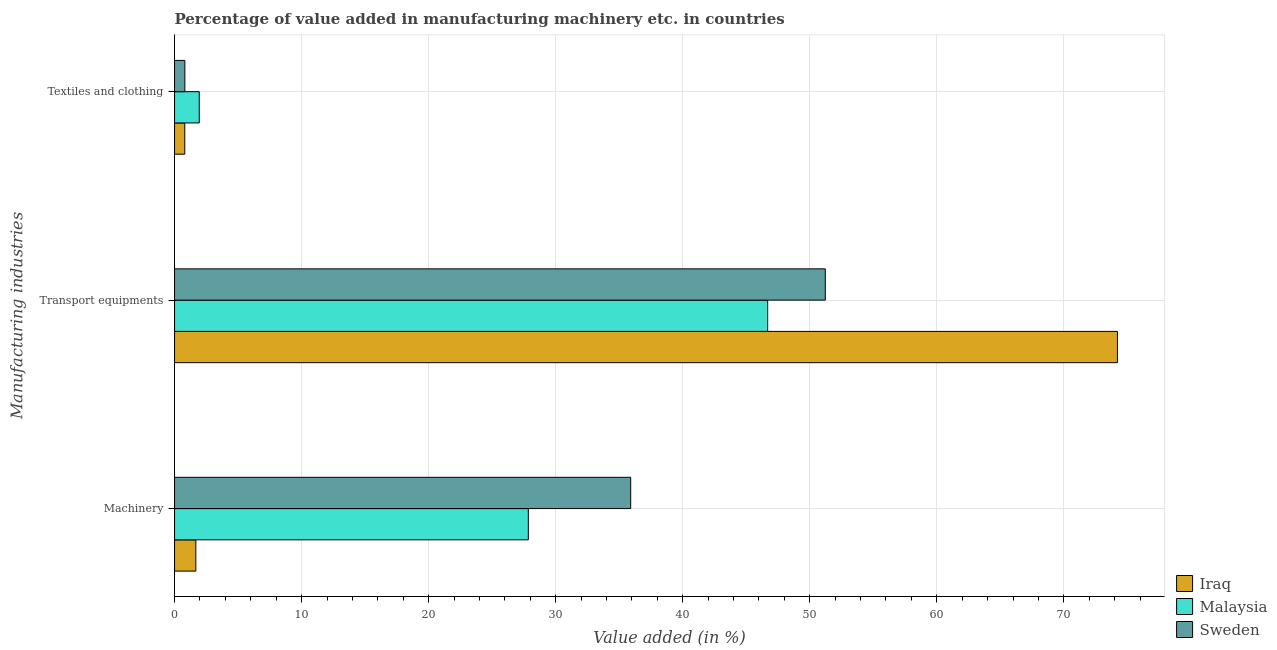How many different coloured bars are there?
Provide a short and direct response. 3. How many groups of bars are there?
Keep it short and to the point. 3. Are the number of bars per tick equal to the number of legend labels?
Offer a terse response. Yes. Are the number of bars on each tick of the Y-axis equal?
Your response must be concise. Yes. What is the label of the 1st group of bars from the top?
Provide a short and direct response. Textiles and clothing. What is the value added in manufacturing textile and clothing in Malaysia?
Your answer should be very brief. 1.95. Across all countries, what is the maximum value added in manufacturing machinery?
Keep it short and to the point. 35.91. Across all countries, what is the minimum value added in manufacturing machinery?
Provide a short and direct response. 1.68. In which country was the value added in manufacturing textile and clothing maximum?
Make the answer very short. Malaysia. In which country was the value added in manufacturing transport equipments minimum?
Offer a terse response. Malaysia. What is the total value added in manufacturing transport equipments in the graph?
Your answer should be compact. 172.14. What is the difference between the value added in manufacturing machinery in Sweden and that in Iraq?
Offer a very short reply. 34.23. What is the difference between the value added in manufacturing textile and clothing in Sweden and the value added in manufacturing machinery in Iraq?
Provide a succinct answer. -0.86. What is the average value added in manufacturing machinery per country?
Offer a terse response. 21.81. What is the difference between the value added in manufacturing textile and clothing and value added in manufacturing transport equipments in Sweden?
Offer a terse response. -50.41. What is the ratio of the value added in manufacturing machinery in Iraq to that in Malaysia?
Make the answer very short. 0.06. Is the difference between the value added in manufacturing machinery in Malaysia and Sweden greater than the difference between the value added in manufacturing textile and clothing in Malaysia and Sweden?
Your answer should be compact. No. What is the difference between the highest and the second highest value added in manufacturing transport equipments?
Your answer should be compact. 23. What is the difference between the highest and the lowest value added in manufacturing textile and clothing?
Your answer should be compact. 1.14. In how many countries, is the value added in manufacturing machinery greater than the average value added in manufacturing machinery taken over all countries?
Offer a very short reply. 2. What does the 3rd bar from the bottom in Machinery represents?
Keep it short and to the point. Sweden. How many bars are there?
Keep it short and to the point. 9. How many countries are there in the graph?
Your answer should be very brief. 3. What is the difference between two consecutive major ticks on the X-axis?
Your response must be concise. 10. Does the graph contain any zero values?
Offer a terse response. No. Does the graph contain grids?
Your answer should be compact. Yes. How many legend labels are there?
Offer a very short reply. 3. What is the title of the graph?
Provide a succinct answer. Percentage of value added in manufacturing machinery etc. in countries. Does "Mongolia" appear as one of the legend labels in the graph?
Offer a terse response. No. What is the label or title of the X-axis?
Ensure brevity in your answer.  Value added (in %). What is the label or title of the Y-axis?
Ensure brevity in your answer.  Manufacturing industries. What is the Value added (in %) in Iraq in Machinery?
Give a very brief answer. 1.68. What is the Value added (in %) in Malaysia in Machinery?
Give a very brief answer. 27.85. What is the Value added (in %) of Sweden in Machinery?
Provide a succinct answer. 35.91. What is the Value added (in %) of Iraq in Transport equipments?
Give a very brief answer. 74.22. What is the Value added (in %) in Malaysia in Transport equipments?
Give a very brief answer. 46.69. What is the Value added (in %) in Sweden in Transport equipments?
Your response must be concise. 51.22. What is the Value added (in %) in Iraq in Textiles and clothing?
Make the answer very short. 0.8. What is the Value added (in %) of Malaysia in Textiles and clothing?
Offer a very short reply. 1.95. What is the Value added (in %) of Sweden in Textiles and clothing?
Your answer should be compact. 0.81. Across all Manufacturing industries, what is the maximum Value added (in %) of Iraq?
Ensure brevity in your answer.  74.22. Across all Manufacturing industries, what is the maximum Value added (in %) in Malaysia?
Give a very brief answer. 46.69. Across all Manufacturing industries, what is the maximum Value added (in %) in Sweden?
Ensure brevity in your answer.  51.22. Across all Manufacturing industries, what is the minimum Value added (in %) in Iraq?
Give a very brief answer. 0.8. Across all Manufacturing industries, what is the minimum Value added (in %) in Malaysia?
Provide a succinct answer. 1.95. Across all Manufacturing industries, what is the minimum Value added (in %) of Sweden?
Offer a terse response. 0.81. What is the total Value added (in %) of Iraq in the graph?
Your answer should be very brief. 76.7. What is the total Value added (in %) in Malaysia in the graph?
Offer a terse response. 76.48. What is the total Value added (in %) of Sweden in the graph?
Offer a very short reply. 87.94. What is the difference between the Value added (in %) of Iraq in Machinery and that in Transport equipments?
Keep it short and to the point. -72.55. What is the difference between the Value added (in %) of Malaysia in Machinery and that in Transport equipments?
Your answer should be very brief. -18.84. What is the difference between the Value added (in %) in Sweden in Machinery and that in Transport equipments?
Make the answer very short. -15.32. What is the difference between the Value added (in %) of Iraq in Machinery and that in Textiles and clothing?
Ensure brevity in your answer.  0.87. What is the difference between the Value added (in %) in Malaysia in Machinery and that in Textiles and clothing?
Ensure brevity in your answer.  25.9. What is the difference between the Value added (in %) in Sweden in Machinery and that in Textiles and clothing?
Provide a short and direct response. 35.09. What is the difference between the Value added (in %) in Iraq in Transport equipments and that in Textiles and clothing?
Your response must be concise. 73.42. What is the difference between the Value added (in %) of Malaysia in Transport equipments and that in Textiles and clothing?
Keep it short and to the point. 44.74. What is the difference between the Value added (in %) in Sweden in Transport equipments and that in Textiles and clothing?
Your answer should be very brief. 50.41. What is the difference between the Value added (in %) in Iraq in Machinery and the Value added (in %) in Malaysia in Transport equipments?
Make the answer very short. -45.01. What is the difference between the Value added (in %) in Iraq in Machinery and the Value added (in %) in Sweden in Transport equipments?
Give a very brief answer. -49.55. What is the difference between the Value added (in %) of Malaysia in Machinery and the Value added (in %) of Sweden in Transport equipments?
Offer a very short reply. -23.38. What is the difference between the Value added (in %) of Iraq in Machinery and the Value added (in %) of Malaysia in Textiles and clothing?
Keep it short and to the point. -0.27. What is the difference between the Value added (in %) of Iraq in Machinery and the Value added (in %) of Sweden in Textiles and clothing?
Keep it short and to the point. 0.86. What is the difference between the Value added (in %) in Malaysia in Machinery and the Value added (in %) in Sweden in Textiles and clothing?
Provide a succinct answer. 27.04. What is the difference between the Value added (in %) in Iraq in Transport equipments and the Value added (in %) in Malaysia in Textiles and clothing?
Ensure brevity in your answer.  72.28. What is the difference between the Value added (in %) of Iraq in Transport equipments and the Value added (in %) of Sweden in Textiles and clothing?
Ensure brevity in your answer.  73.41. What is the difference between the Value added (in %) in Malaysia in Transport equipments and the Value added (in %) in Sweden in Textiles and clothing?
Provide a succinct answer. 45.88. What is the average Value added (in %) of Iraq per Manufacturing industries?
Provide a short and direct response. 25.57. What is the average Value added (in %) of Malaysia per Manufacturing industries?
Provide a succinct answer. 25.49. What is the average Value added (in %) of Sweden per Manufacturing industries?
Give a very brief answer. 29.31. What is the difference between the Value added (in %) of Iraq and Value added (in %) of Malaysia in Machinery?
Offer a very short reply. -26.17. What is the difference between the Value added (in %) in Iraq and Value added (in %) in Sweden in Machinery?
Your answer should be compact. -34.23. What is the difference between the Value added (in %) of Malaysia and Value added (in %) of Sweden in Machinery?
Offer a very short reply. -8.06. What is the difference between the Value added (in %) in Iraq and Value added (in %) in Malaysia in Transport equipments?
Provide a short and direct response. 27.53. What is the difference between the Value added (in %) of Iraq and Value added (in %) of Sweden in Transport equipments?
Your answer should be compact. 23. What is the difference between the Value added (in %) in Malaysia and Value added (in %) in Sweden in Transport equipments?
Offer a very short reply. -4.54. What is the difference between the Value added (in %) in Iraq and Value added (in %) in Malaysia in Textiles and clothing?
Your answer should be compact. -1.14. What is the difference between the Value added (in %) in Iraq and Value added (in %) in Sweden in Textiles and clothing?
Your answer should be very brief. -0.01. What is the difference between the Value added (in %) of Malaysia and Value added (in %) of Sweden in Textiles and clothing?
Keep it short and to the point. 1.13. What is the ratio of the Value added (in %) of Iraq in Machinery to that in Transport equipments?
Give a very brief answer. 0.02. What is the ratio of the Value added (in %) in Malaysia in Machinery to that in Transport equipments?
Give a very brief answer. 0.6. What is the ratio of the Value added (in %) of Sweden in Machinery to that in Transport equipments?
Provide a short and direct response. 0.7. What is the ratio of the Value added (in %) of Iraq in Machinery to that in Textiles and clothing?
Give a very brief answer. 2.09. What is the ratio of the Value added (in %) in Malaysia in Machinery to that in Textiles and clothing?
Give a very brief answer. 14.31. What is the ratio of the Value added (in %) of Sweden in Machinery to that in Textiles and clothing?
Your answer should be compact. 44.23. What is the ratio of the Value added (in %) of Iraq in Transport equipments to that in Textiles and clothing?
Offer a terse response. 92.32. What is the ratio of the Value added (in %) in Malaysia in Transport equipments to that in Textiles and clothing?
Make the answer very short. 24. What is the ratio of the Value added (in %) of Sweden in Transport equipments to that in Textiles and clothing?
Provide a succinct answer. 63.1. What is the difference between the highest and the second highest Value added (in %) of Iraq?
Offer a very short reply. 72.55. What is the difference between the highest and the second highest Value added (in %) of Malaysia?
Keep it short and to the point. 18.84. What is the difference between the highest and the second highest Value added (in %) in Sweden?
Make the answer very short. 15.32. What is the difference between the highest and the lowest Value added (in %) of Iraq?
Give a very brief answer. 73.42. What is the difference between the highest and the lowest Value added (in %) in Malaysia?
Provide a short and direct response. 44.74. What is the difference between the highest and the lowest Value added (in %) in Sweden?
Offer a very short reply. 50.41. 